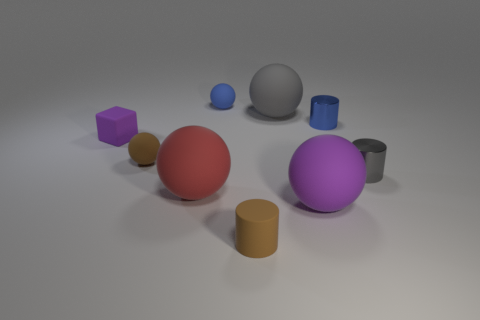Add 1 tiny metal balls. How many objects exist? 10 Subtract all cylinders. How many objects are left? 6 Subtract all brown cylinders. How many cylinders are left? 2 Subtract all shiny cylinders. How many cylinders are left? 1 Add 7 tiny gray cylinders. How many tiny gray cylinders are left? 8 Add 3 small gray things. How many small gray things exist? 4 Subtract 1 blue cylinders. How many objects are left? 8 Subtract 3 balls. How many balls are left? 2 Subtract all yellow blocks. Subtract all brown balls. How many blocks are left? 1 Subtract all yellow cubes. How many brown cylinders are left? 1 